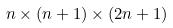Convert formula to latex. <formula><loc_0><loc_0><loc_500><loc_500>n \times ( n + 1 ) \times ( 2 n + 1 )</formula> 